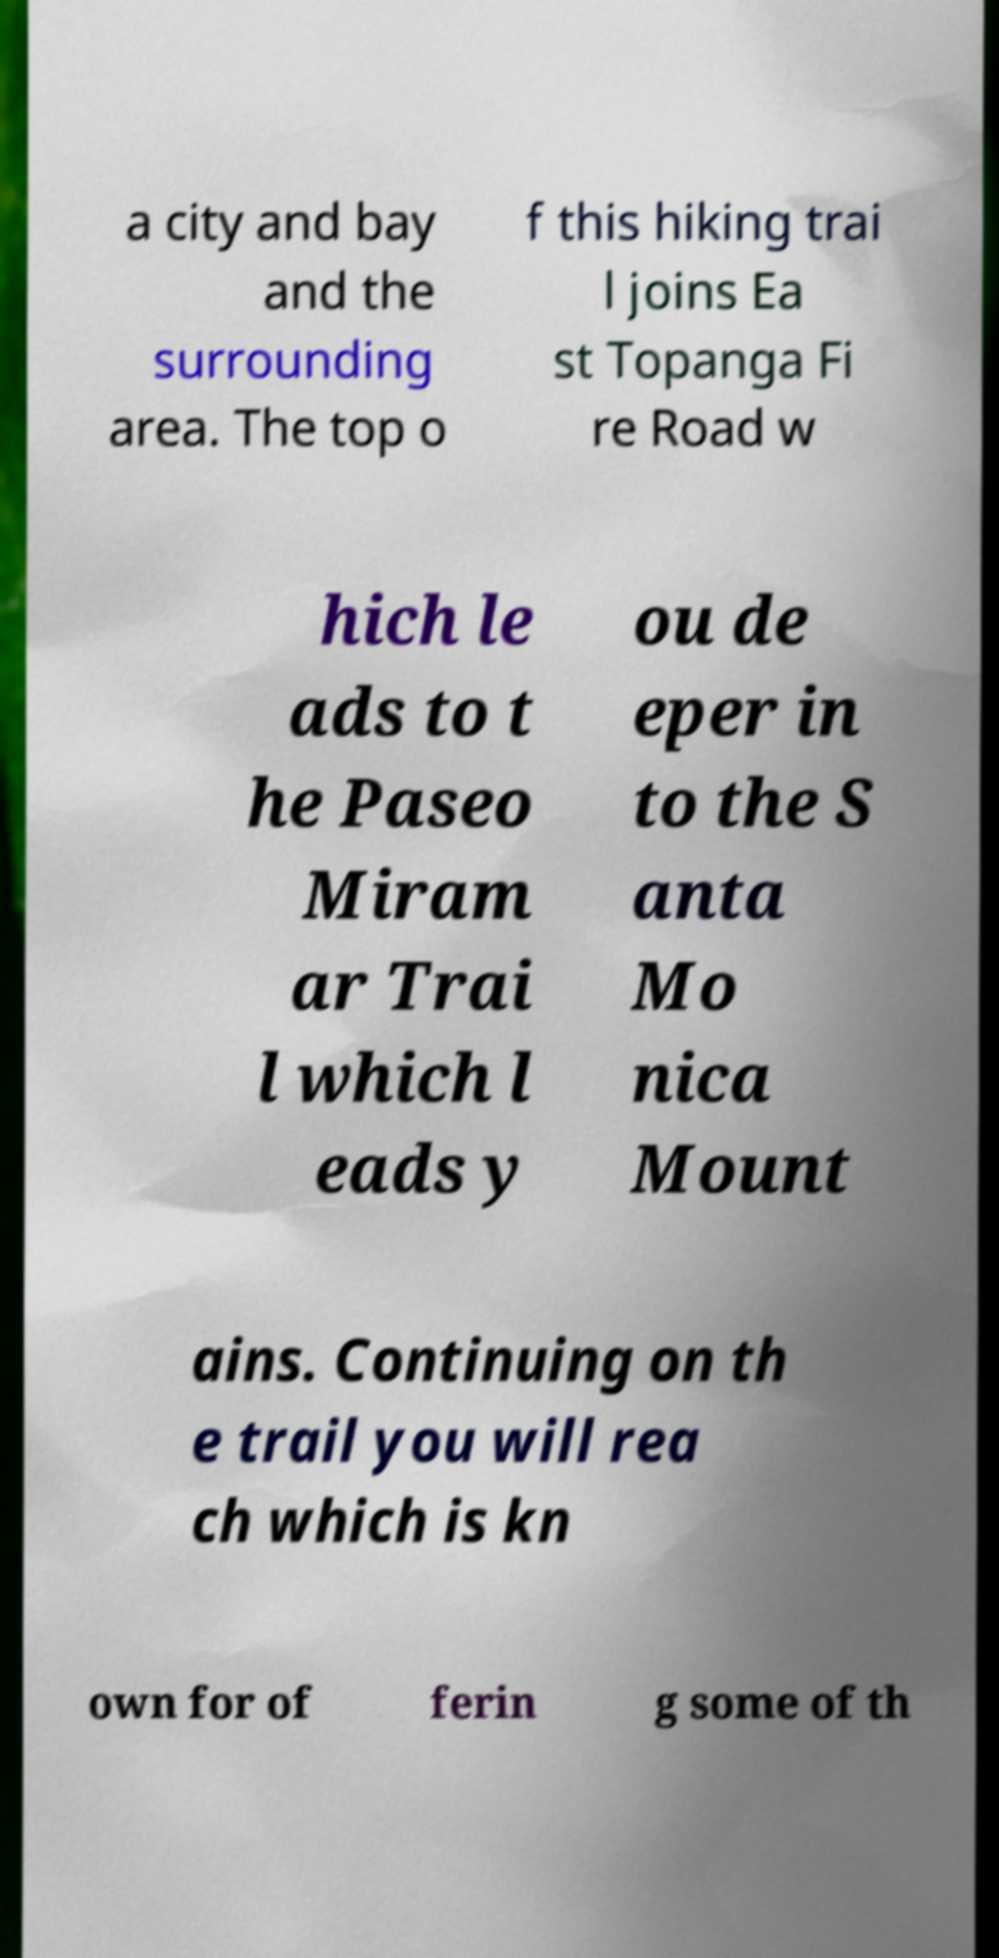For documentation purposes, I need the text within this image transcribed. Could you provide that? a city and bay and the surrounding area. The top o f this hiking trai l joins Ea st Topanga Fi re Road w hich le ads to t he Paseo Miram ar Trai l which l eads y ou de eper in to the S anta Mo nica Mount ains. Continuing on th e trail you will rea ch which is kn own for of ferin g some of th 